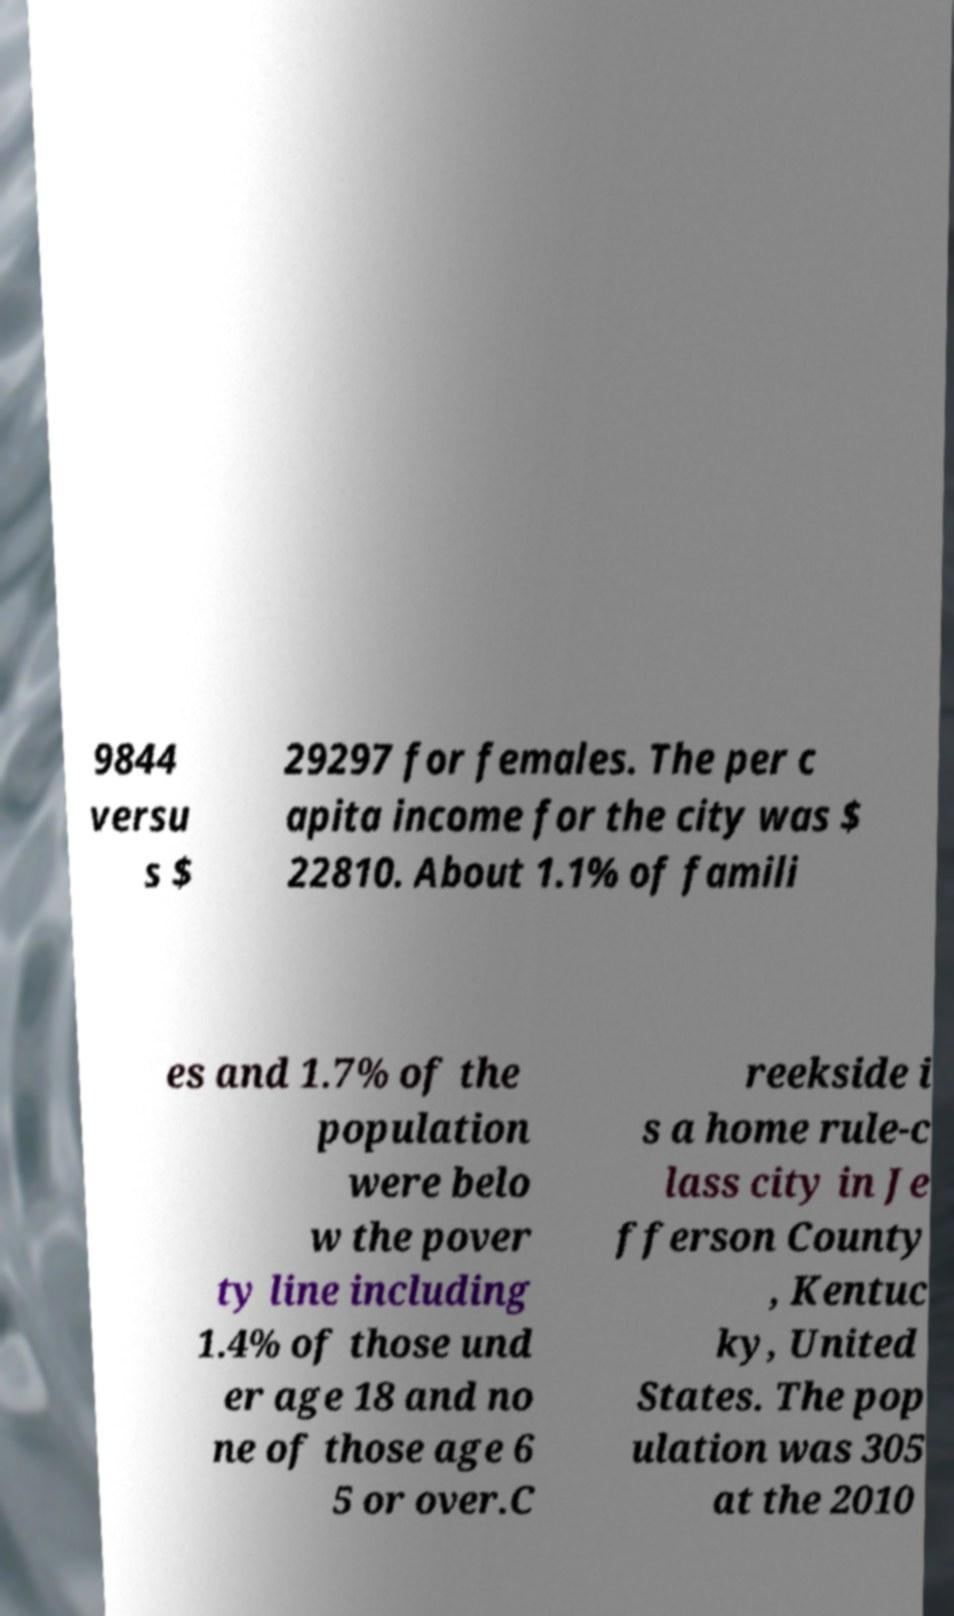Please identify and transcribe the text found in this image. 9844 versu s $ 29297 for females. The per c apita income for the city was $ 22810. About 1.1% of famili es and 1.7% of the population were belo w the pover ty line including 1.4% of those und er age 18 and no ne of those age 6 5 or over.C reekside i s a home rule-c lass city in Je fferson County , Kentuc ky, United States. The pop ulation was 305 at the 2010 